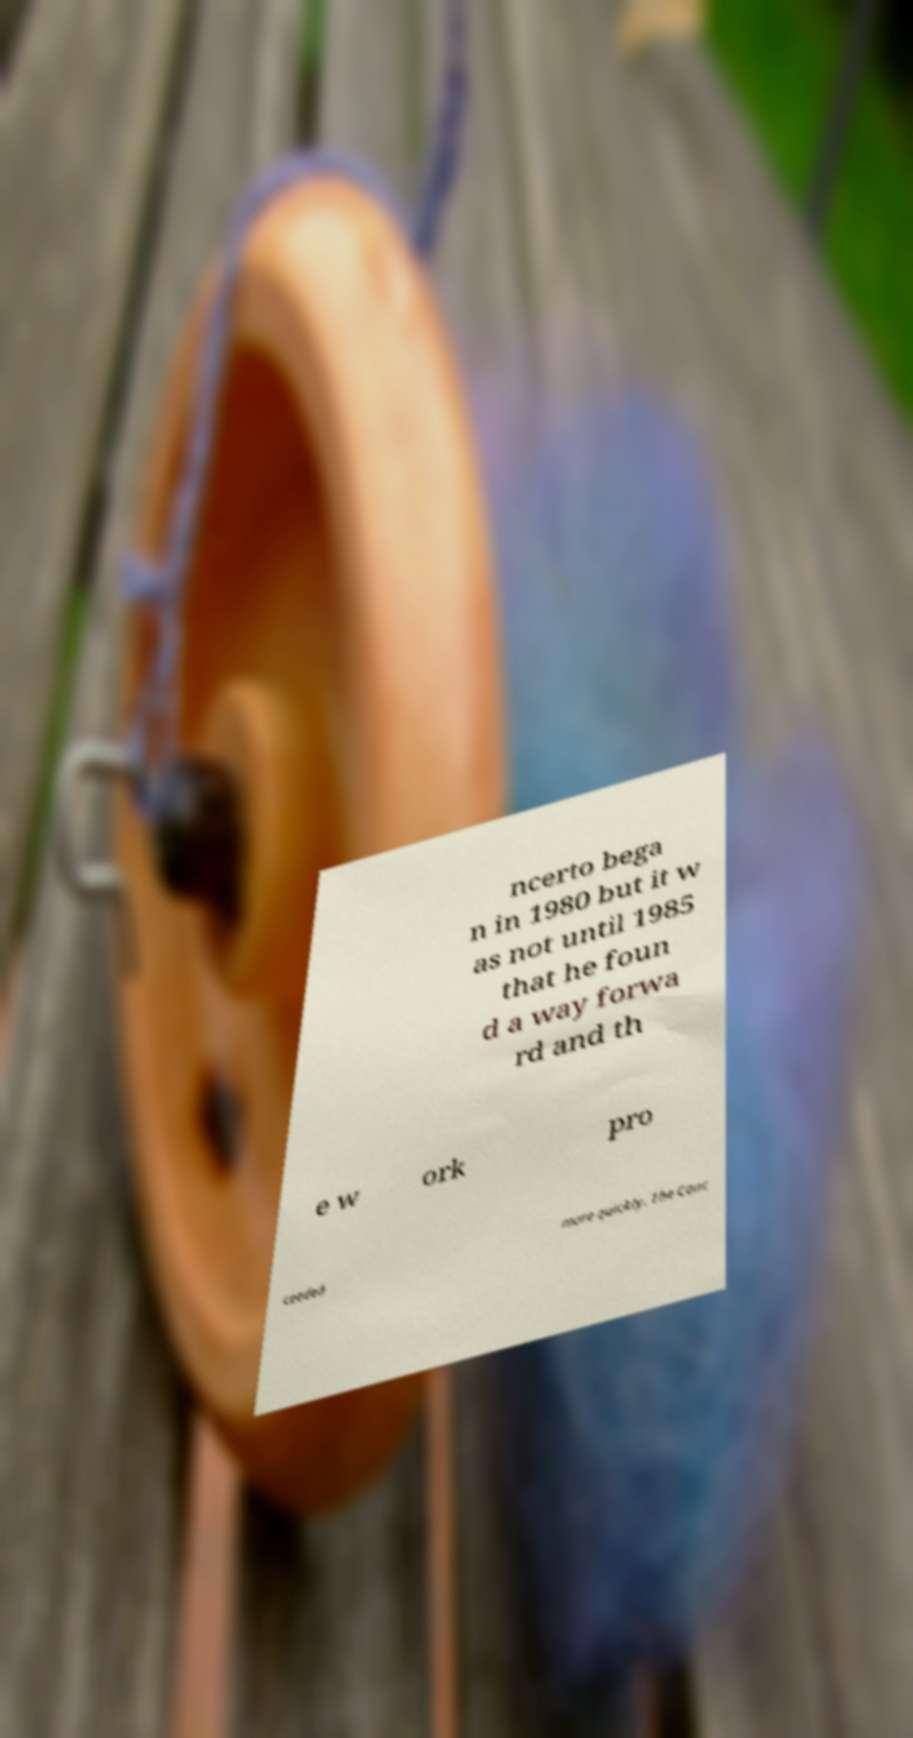Can you accurately transcribe the text from the provided image for me? ncerto bega n in 1980 but it w as not until 1985 that he foun d a way forwa rd and th e w ork pro ceeded more quickly. The Conc 